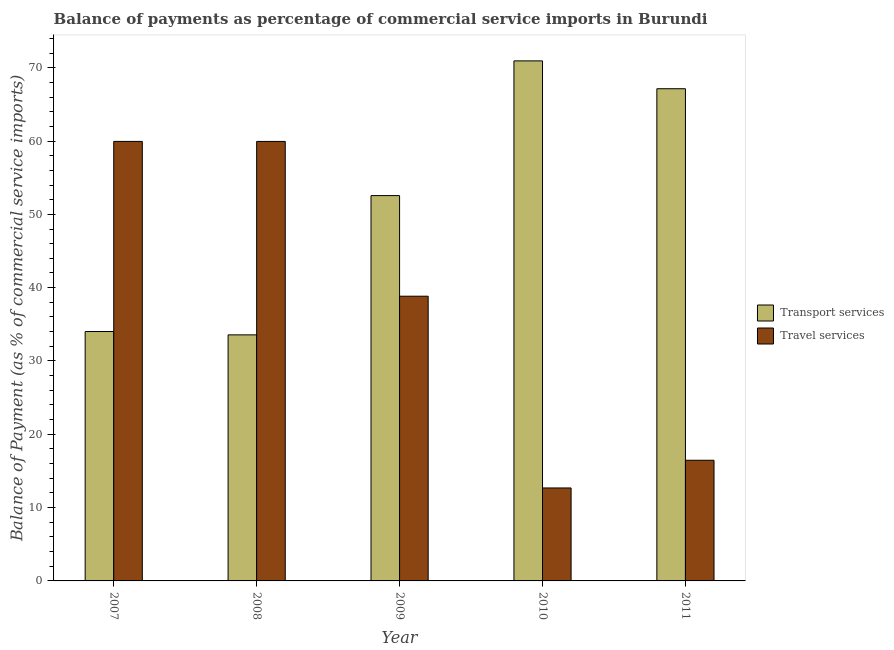How many groups of bars are there?
Your answer should be very brief. 5. Are the number of bars per tick equal to the number of legend labels?
Your answer should be compact. Yes. In how many cases, is the number of bars for a given year not equal to the number of legend labels?
Make the answer very short. 0. What is the balance of payments of transport services in 2011?
Offer a terse response. 67.13. Across all years, what is the maximum balance of payments of travel services?
Your response must be concise. 59.95. Across all years, what is the minimum balance of payments of travel services?
Provide a short and direct response. 12.68. In which year was the balance of payments of travel services maximum?
Provide a short and direct response. 2007. What is the total balance of payments of travel services in the graph?
Provide a succinct answer. 187.86. What is the difference between the balance of payments of transport services in 2007 and that in 2008?
Your answer should be very brief. 0.46. What is the difference between the balance of payments of transport services in 2008 and the balance of payments of travel services in 2010?
Provide a short and direct response. -37.37. What is the average balance of payments of travel services per year?
Keep it short and to the point. 37.57. What is the ratio of the balance of payments of transport services in 2009 to that in 2010?
Offer a terse response. 0.74. Is the difference between the balance of payments of transport services in 2007 and 2011 greater than the difference between the balance of payments of travel services in 2007 and 2011?
Your answer should be compact. No. What is the difference between the highest and the second highest balance of payments of transport services?
Provide a short and direct response. 3.8. What is the difference between the highest and the lowest balance of payments of travel services?
Your response must be concise. 47.27. In how many years, is the balance of payments of transport services greater than the average balance of payments of transport services taken over all years?
Keep it short and to the point. 3. What does the 1st bar from the left in 2009 represents?
Your response must be concise. Transport services. What does the 1st bar from the right in 2008 represents?
Provide a succinct answer. Travel services. Are all the bars in the graph horizontal?
Your answer should be compact. No. How many years are there in the graph?
Provide a succinct answer. 5. What is the difference between two consecutive major ticks on the Y-axis?
Make the answer very short. 10. Are the values on the major ticks of Y-axis written in scientific E-notation?
Offer a terse response. No. Does the graph contain grids?
Make the answer very short. No. How are the legend labels stacked?
Your response must be concise. Vertical. What is the title of the graph?
Your answer should be very brief. Balance of payments as percentage of commercial service imports in Burundi. What is the label or title of the X-axis?
Give a very brief answer. Year. What is the label or title of the Y-axis?
Give a very brief answer. Balance of Payment (as % of commercial service imports). What is the Balance of Payment (as % of commercial service imports) in Transport services in 2007?
Offer a terse response. 34.02. What is the Balance of Payment (as % of commercial service imports) in Travel services in 2007?
Make the answer very short. 59.95. What is the Balance of Payment (as % of commercial service imports) in Transport services in 2008?
Keep it short and to the point. 33.56. What is the Balance of Payment (as % of commercial service imports) in Travel services in 2008?
Make the answer very short. 59.94. What is the Balance of Payment (as % of commercial service imports) of Transport services in 2009?
Provide a succinct answer. 52.56. What is the Balance of Payment (as % of commercial service imports) in Travel services in 2009?
Give a very brief answer. 38.83. What is the Balance of Payment (as % of commercial service imports) of Transport services in 2010?
Keep it short and to the point. 70.93. What is the Balance of Payment (as % of commercial service imports) of Travel services in 2010?
Offer a terse response. 12.68. What is the Balance of Payment (as % of commercial service imports) in Transport services in 2011?
Make the answer very short. 67.13. What is the Balance of Payment (as % of commercial service imports) of Travel services in 2011?
Give a very brief answer. 16.46. Across all years, what is the maximum Balance of Payment (as % of commercial service imports) of Transport services?
Keep it short and to the point. 70.93. Across all years, what is the maximum Balance of Payment (as % of commercial service imports) of Travel services?
Your answer should be very brief. 59.95. Across all years, what is the minimum Balance of Payment (as % of commercial service imports) of Transport services?
Offer a very short reply. 33.56. Across all years, what is the minimum Balance of Payment (as % of commercial service imports) of Travel services?
Your answer should be very brief. 12.68. What is the total Balance of Payment (as % of commercial service imports) in Transport services in the graph?
Provide a succinct answer. 258.2. What is the total Balance of Payment (as % of commercial service imports) of Travel services in the graph?
Make the answer very short. 187.86. What is the difference between the Balance of Payment (as % of commercial service imports) in Transport services in 2007 and that in 2008?
Your answer should be very brief. 0.46. What is the difference between the Balance of Payment (as % of commercial service imports) in Travel services in 2007 and that in 2008?
Offer a very short reply. 0. What is the difference between the Balance of Payment (as % of commercial service imports) of Transport services in 2007 and that in 2009?
Give a very brief answer. -18.54. What is the difference between the Balance of Payment (as % of commercial service imports) of Travel services in 2007 and that in 2009?
Offer a terse response. 21.11. What is the difference between the Balance of Payment (as % of commercial service imports) of Transport services in 2007 and that in 2010?
Offer a very short reply. -36.91. What is the difference between the Balance of Payment (as % of commercial service imports) of Travel services in 2007 and that in 2010?
Make the answer very short. 47.27. What is the difference between the Balance of Payment (as % of commercial service imports) in Transport services in 2007 and that in 2011?
Provide a short and direct response. -33.11. What is the difference between the Balance of Payment (as % of commercial service imports) of Travel services in 2007 and that in 2011?
Ensure brevity in your answer.  43.49. What is the difference between the Balance of Payment (as % of commercial service imports) in Transport services in 2008 and that in 2009?
Your answer should be compact. -18.99. What is the difference between the Balance of Payment (as % of commercial service imports) in Travel services in 2008 and that in 2009?
Make the answer very short. 21.11. What is the difference between the Balance of Payment (as % of commercial service imports) of Transport services in 2008 and that in 2010?
Give a very brief answer. -37.37. What is the difference between the Balance of Payment (as % of commercial service imports) in Travel services in 2008 and that in 2010?
Provide a short and direct response. 47.27. What is the difference between the Balance of Payment (as % of commercial service imports) of Transport services in 2008 and that in 2011?
Keep it short and to the point. -33.57. What is the difference between the Balance of Payment (as % of commercial service imports) of Travel services in 2008 and that in 2011?
Your response must be concise. 43.49. What is the difference between the Balance of Payment (as % of commercial service imports) in Transport services in 2009 and that in 2010?
Provide a short and direct response. -18.38. What is the difference between the Balance of Payment (as % of commercial service imports) in Travel services in 2009 and that in 2010?
Your answer should be very brief. 26.16. What is the difference between the Balance of Payment (as % of commercial service imports) of Transport services in 2009 and that in 2011?
Provide a short and direct response. -14.58. What is the difference between the Balance of Payment (as % of commercial service imports) in Travel services in 2009 and that in 2011?
Offer a terse response. 22.37. What is the difference between the Balance of Payment (as % of commercial service imports) in Transport services in 2010 and that in 2011?
Offer a very short reply. 3.8. What is the difference between the Balance of Payment (as % of commercial service imports) of Travel services in 2010 and that in 2011?
Your response must be concise. -3.78. What is the difference between the Balance of Payment (as % of commercial service imports) in Transport services in 2007 and the Balance of Payment (as % of commercial service imports) in Travel services in 2008?
Provide a succinct answer. -25.93. What is the difference between the Balance of Payment (as % of commercial service imports) of Transport services in 2007 and the Balance of Payment (as % of commercial service imports) of Travel services in 2009?
Provide a short and direct response. -4.82. What is the difference between the Balance of Payment (as % of commercial service imports) in Transport services in 2007 and the Balance of Payment (as % of commercial service imports) in Travel services in 2010?
Ensure brevity in your answer.  21.34. What is the difference between the Balance of Payment (as % of commercial service imports) of Transport services in 2007 and the Balance of Payment (as % of commercial service imports) of Travel services in 2011?
Give a very brief answer. 17.56. What is the difference between the Balance of Payment (as % of commercial service imports) of Transport services in 2008 and the Balance of Payment (as % of commercial service imports) of Travel services in 2009?
Your response must be concise. -5.27. What is the difference between the Balance of Payment (as % of commercial service imports) of Transport services in 2008 and the Balance of Payment (as % of commercial service imports) of Travel services in 2010?
Give a very brief answer. 20.88. What is the difference between the Balance of Payment (as % of commercial service imports) in Transport services in 2008 and the Balance of Payment (as % of commercial service imports) in Travel services in 2011?
Provide a succinct answer. 17.1. What is the difference between the Balance of Payment (as % of commercial service imports) of Transport services in 2009 and the Balance of Payment (as % of commercial service imports) of Travel services in 2010?
Give a very brief answer. 39.88. What is the difference between the Balance of Payment (as % of commercial service imports) in Transport services in 2009 and the Balance of Payment (as % of commercial service imports) in Travel services in 2011?
Keep it short and to the point. 36.1. What is the difference between the Balance of Payment (as % of commercial service imports) of Transport services in 2010 and the Balance of Payment (as % of commercial service imports) of Travel services in 2011?
Offer a very short reply. 54.47. What is the average Balance of Payment (as % of commercial service imports) of Transport services per year?
Your response must be concise. 51.64. What is the average Balance of Payment (as % of commercial service imports) of Travel services per year?
Make the answer very short. 37.57. In the year 2007, what is the difference between the Balance of Payment (as % of commercial service imports) of Transport services and Balance of Payment (as % of commercial service imports) of Travel services?
Offer a very short reply. -25.93. In the year 2008, what is the difference between the Balance of Payment (as % of commercial service imports) of Transport services and Balance of Payment (as % of commercial service imports) of Travel services?
Offer a very short reply. -26.38. In the year 2009, what is the difference between the Balance of Payment (as % of commercial service imports) of Transport services and Balance of Payment (as % of commercial service imports) of Travel services?
Your response must be concise. 13.72. In the year 2010, what is the difference between the Balance of Payment (as % of commercial service imports) in Transport services and Balance of Payment (as % of commercial service imports) in Travel services?
Your response must be concise. 58.25. In the year 2011, what is the difference between the Balance of Payment (as % of commercial service imports) in Transport services and Balance of Payment (as % of commercial service imports) in Travel services?
Your answer should be compact. 50.67. What is the ratio of the Balance of Payment (as % of commercial service imports) of Transport services in 2007 to that in 2008?
Your answer should be compact. 1.01. What is the ratio of the Balance of Payment (as % of commercial service imports) of Transport services in 2007 to that in 2009?
Provide a succinct answer. 0.65. What is the ratio of the Balance of Payment (as % of commercial service imports) of Travel services in 2007 to that in 2009?
Your answer should be compact. 1.54. What is the ratio of the Balance of Payment (as % of commercial service imports) of Transport services in 2007 to that in 2010?
Keep it short and to the point. 0.48. What is the ratio of the Balance of Payment (as % of commercial service imports) in Travel services in 2007 to that in 2010?
Keep it short and to the point. 4.73. What is the ratio of the Balance of Payment (as % of commercial service imports) in Transport services in 2007 to that in 2011?
Your answer should be very brief. 0.51. What is the ratio of the Balance of Payment (as % of commercial service imports) of Travel services in 2007 to that in 2011?
Provide a succinct answer. 3.64. What is the ratio of the Balance of Payment (as % of commercial service imports) in Transport services in 2008 to that in 2009?
Your answer should be compact. 0.64. What is the ratio of the Balance of Payment (as % of commercial service imports) of Travel services in 2008 to that in 2009?
Keep it short and to the point. 1.54. What is the ratio of the Balance of Payment (as % of commercial service imports) of Transport services in 2008 to that in 2010?
Ensure brevity in your answer.  0.47. What is the ratio of the Balance of Payment (as % of commercial service imports) in Travel services in 2008 to that in 2010?
Your answer should be very brief. 4.73. What is the ratio of the Balance of Payment (as % of commercial service imports) in Transport services in 2008 to that in 2011?
Make the answer very short. 0.5. What is the ratio of the Balance of Payment (as % of commercial service imports) in Travel services in 2008 to that in 2011?
Your answer should be very brief. 3.64. What is the ratio of the Balance of Payment (as % of commercial service imports) of Transport services in 2009 to that in 2010?
Your answer should be compact. 0.74. What is the ratio of the Balance of Payment (as % of commercial service imports) in Travel services in 2009 to that in 2010?
Give a very brief answer. 3.06. What is the ratio of the Balance of Payment (as % of commercial service imports) in Transport services in 2009 to that in 2011?
Give a very brief answer. 0.78. What is the ratio of the Balance of Payment (as % of commercial service imports) in Travel services in 2009 to that in 2011?
Make the answer very short. 2.36. What is the ratio of the Balance of Payment (as % of commercial service imports) of Transport services in 2010 to that in 2011?
Your answer should be very brief. 1.06. What is the ratio of the Balance of Payment (as % of commercial service imports) of Travel services in 2010 to that in 2011?
Provide a short and direct response. 0.77. What is the difference between the highest and the second highest Balance of Payment (as % of commercial service imports) of Transport services?
Make the answer very short. 3.8. What is the difference between the highest and the second highest Balance of Payment (as % of commercial service imports) of Travel services?
Your answer should be compact. 0. What is the difference between the highest and the lowest Balance of Payment (as % of commercial service imports) in Transport services?
Provide a succinct answer. 37.37. What is the difference between the highest and the lowest Balance of Payment (as % of commercial service imports) of Travel services?
Offer a terse response. 47.27. 